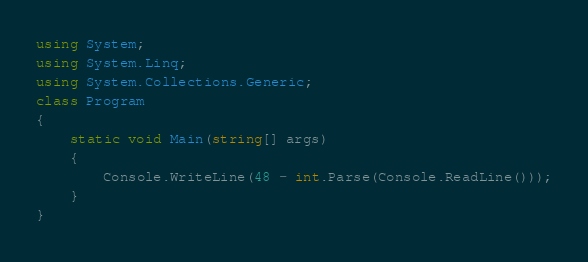<code> <loc_0><loc_0><loc_500><loc_500><_C#_>using System;
using System.Linq;
using System.Collections.Generic;
class Program
{
    static void Main(string[] args)
    {
        Console.WriteLine(48 - int.Parse(Console.ReadLine()));
    }
}
</code> 